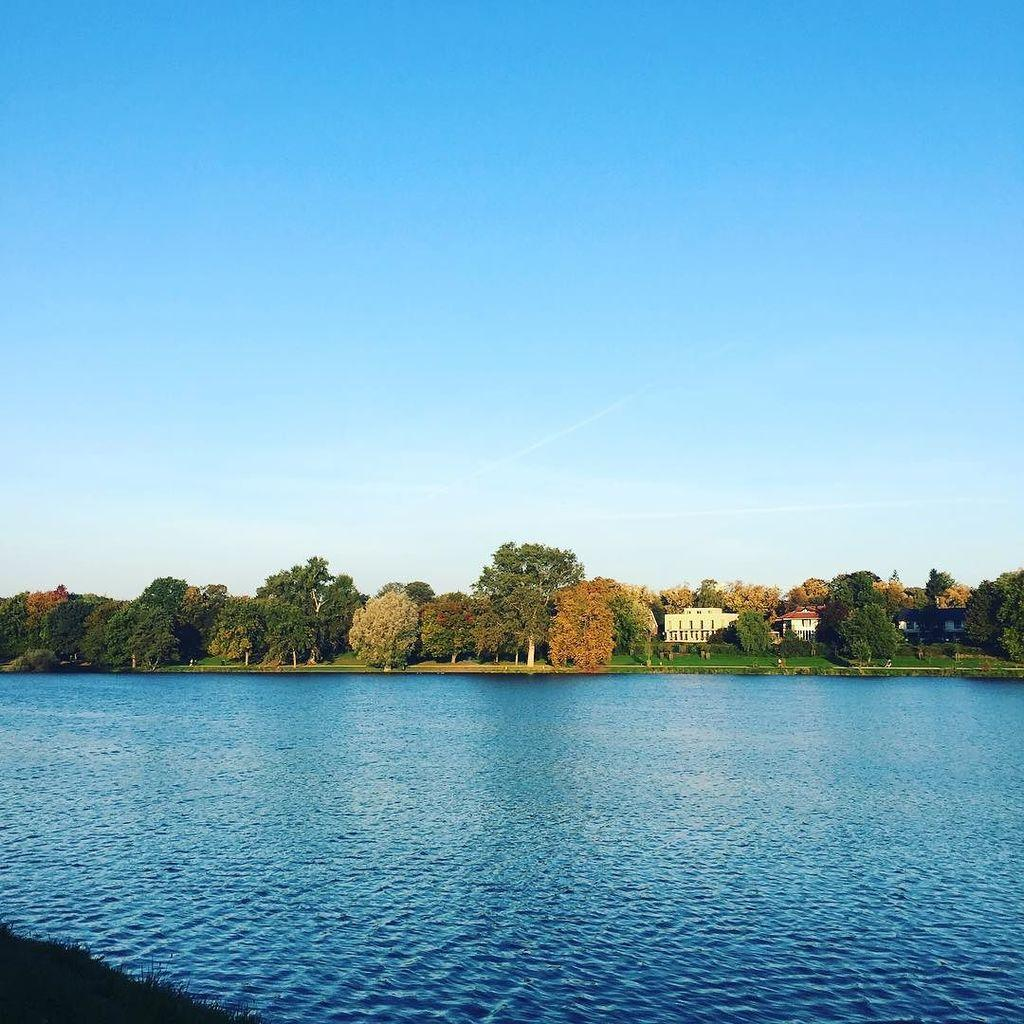What is present at the bottom of the image? There is water at the bottom of the image. What type of vegetation can be seen in the left bottom corner of the image? There is grass in the left bottom corner of the image. What can be seen in the background of the image? There are trees, buildings, and clouds in the sky in the background of the image. What type of rock is being used as a nose by the tree in the image? There is no tree or rock being used as a nose in the image. 